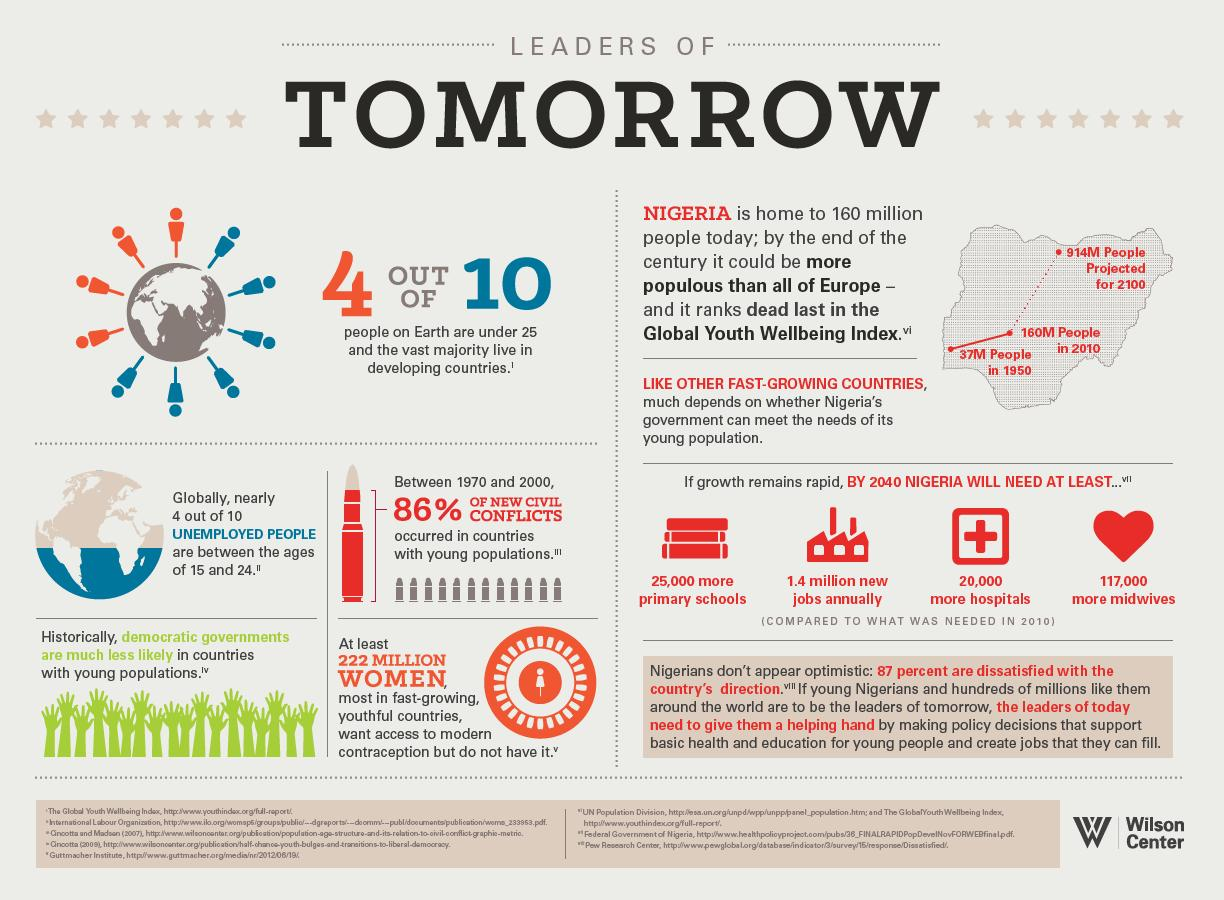Indicate a few pertinent items in this graphic. According to the data, out of the total number of people on Earth, a significant percentage, which is approximately 6 out of 10, did not live in developing countries. The majority of these individuals did not live in developing countries. A recent study has found that only 14% of new civil conflicts occurred in countries with a large youth population. Out of 10, approximately 6% of the unemployed population is not between the ages of 15 and 24. 